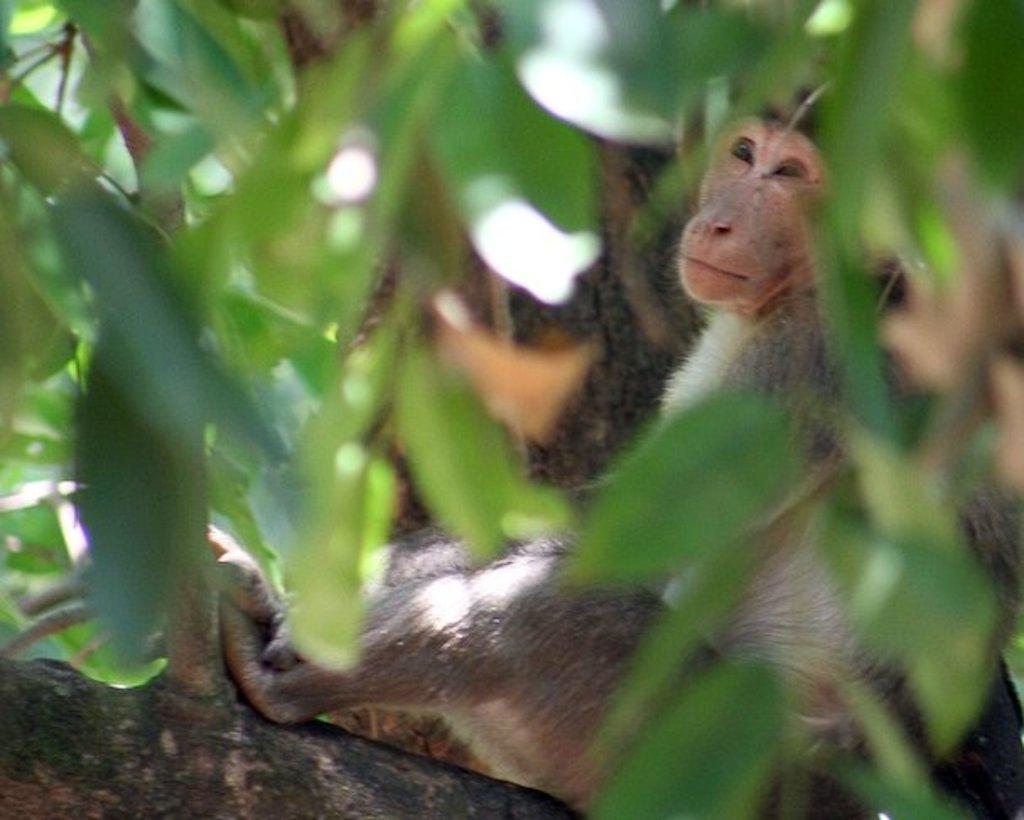Please provide a concise description of this image. This image is taken outdoors. In this image there is a tree and in the middle of the image there is a monkey on the tree. 